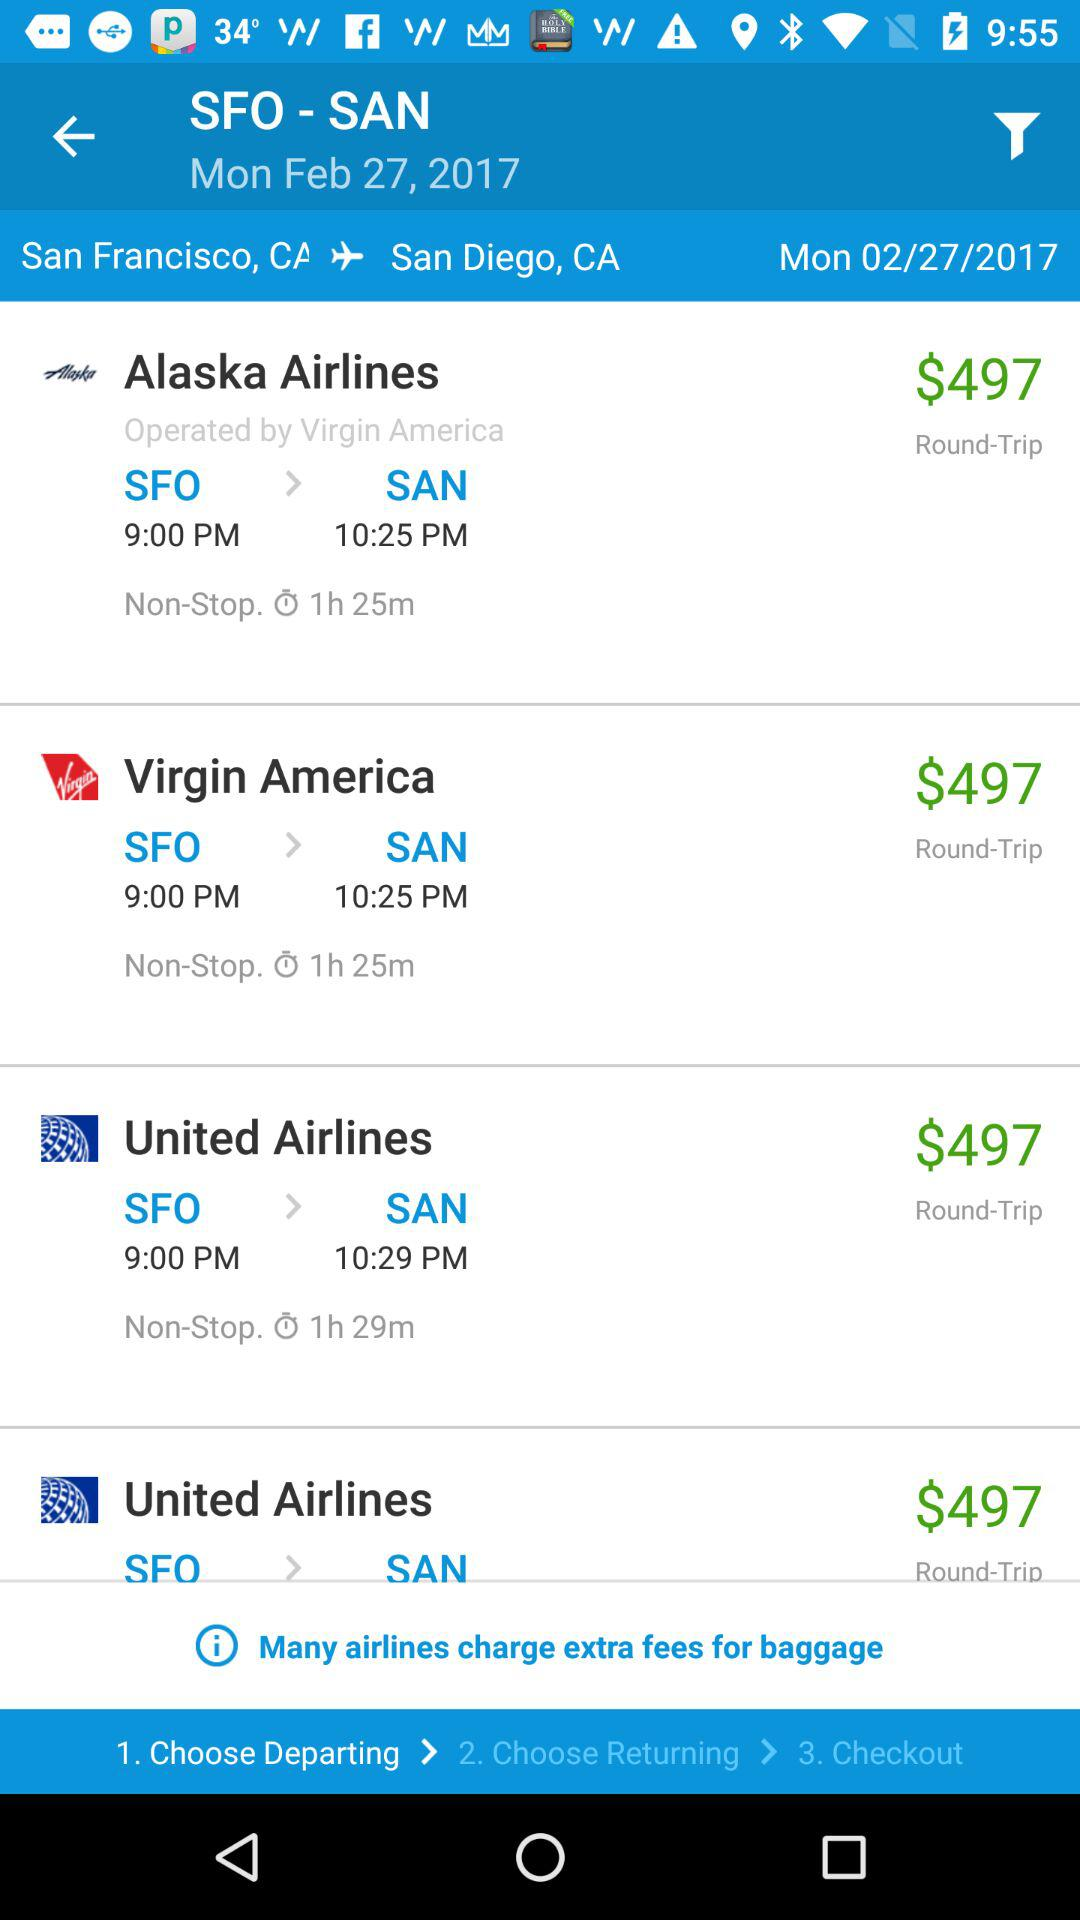What is the price of the "United Airlines" ticket? The price is $497. 